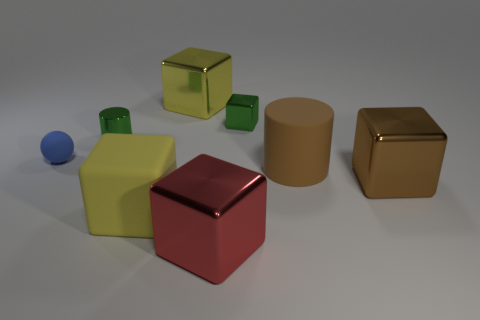Is the tiny block the same color as the rubber cube?
Offer a very short reply. No. There is a metallic cube on the right side of the small green metallic object right of the yellow matte block; how many green metallic cubes are on the right side of it?
Provide a succinct answer. 0. There is a yellow thing that is the same material as the small sphere; what shape is it?
Offer a terse response. Cube. What material is the yellow cube in front of the big metallic cube behind the tiny object that is left of the tiny green metallic cylinder?
Ensure brevity in your answer.  Rubber. How many objects are either large shiny things in front of the rubber cylinder or big metal objects?
Offer a terse response. 3. How many other things are there of the same shape as the large brown metallic object?
Offer a terse response. 4. Are there more large rubber cubes on the right side of the blue thing than tiny purple matte cylinders?
Your answer should be very brief. Yes. There is a metallic object that is the same shape as the brown rubber thing; what is its size?
Provide a succinct answer. Small. Is there anything else that is the same material as the tiny green block?
Ensure brevity in your answer.  Yes. There is a large yellow matte object; what shape is it?
Ensure brevity in your answer.  Cube. 